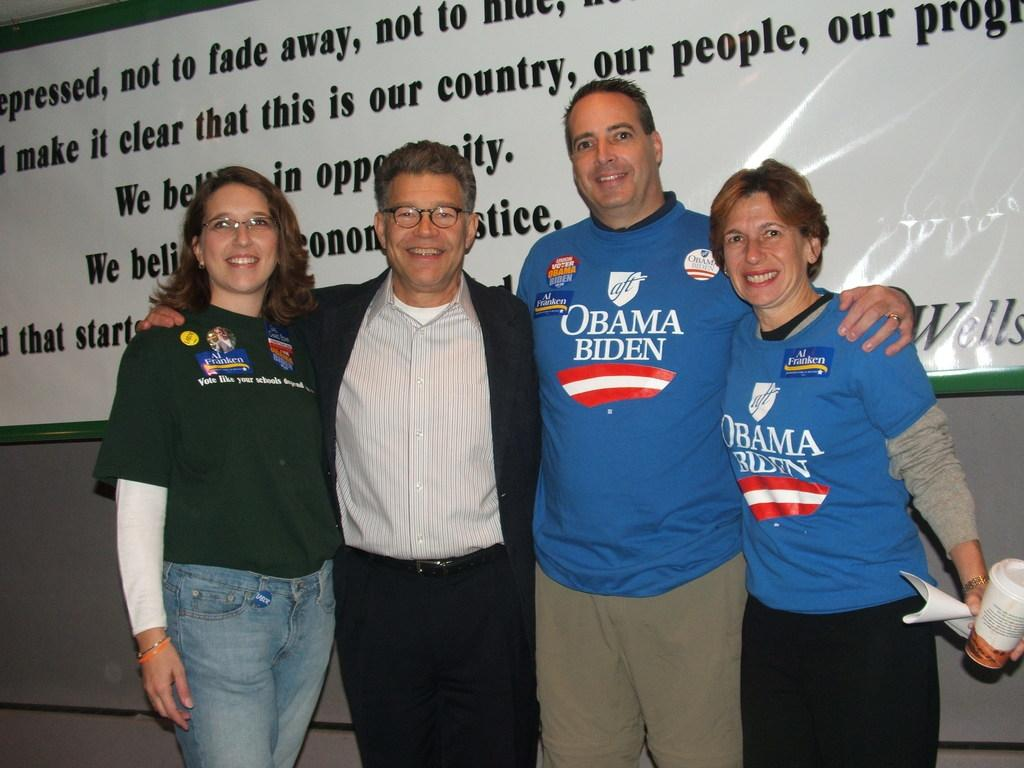Provide a one-sentence caption for the provided image. 2 men and 2 women embraced with a couple wearing Obama/Biden shirts. 